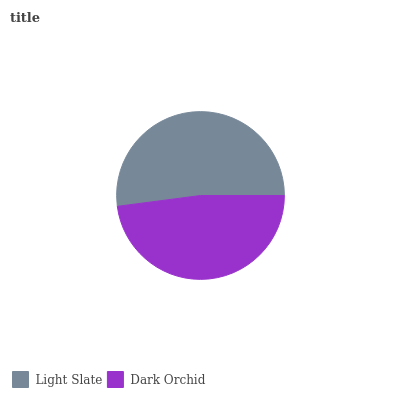Is Dark Orchid the minimum?
Answer yes or no. Yes. Is Light Slate the maximum?
Answer yes or no. Yes. Is Dark Orchid the maximum?
Answer yes or no. No. Is Light Slate greater than Dark Orchid?
Answer yes or no. Yes. Is Dark Orchid less than Light Slate?
Answer yes or no. Yes. Is Dark Orchid greater than Light Slate?
Answer yes or no. No. Is Light Slate less than Dark Orchid?
Answer yes or no. No. Is Light Slate the high median?
Answer yes or no. Yes. Is Dark Orchid the low median?
Answer yes or no. Yes. Is Dark Orchid the high median?
Answer yes or no. No. Is Light Slate the low median?
Answer yes or no. No. 